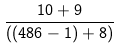Convert formula to latex. <formula><loc_0><loc_0><loc_500><loc_500>\frac { 1 0 + 9 } { ( ( 4 8 6 - 1 ) + 8 ) }</formula> 